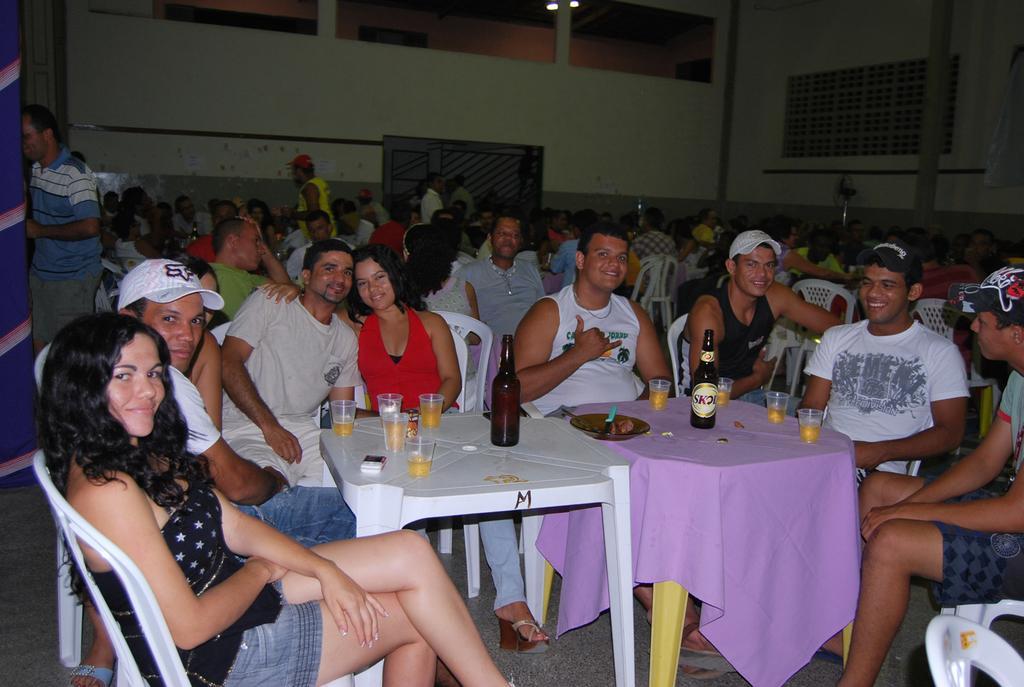Could you give a brief overview of what you see in this image? It is a big room , there are lot of people sitting around the tables few people are standing, people who are sitting in the first row are posing for the photo there are two tables in front of them on which some glasses and bottles are placed in the background there is a wall. 